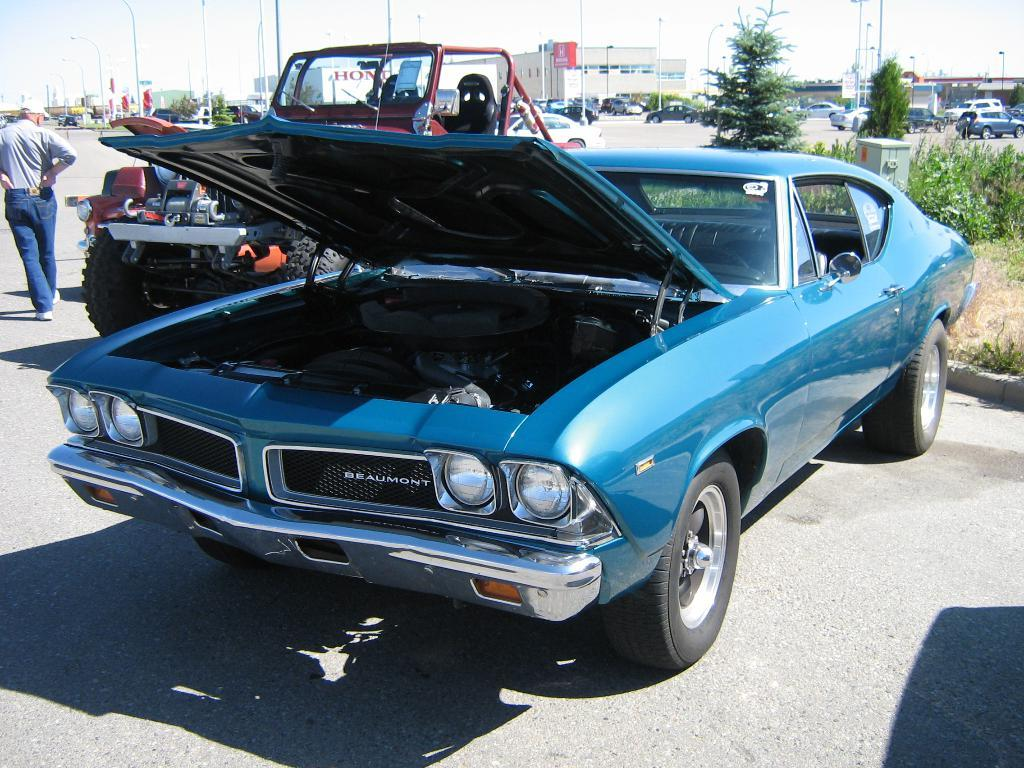What can be seen on the road in the image? There are vehicles on the road in the image. What is the man on the left side of the image doing? There is a man walking on the left side of the image. What can be seen in the background of the image? There are buildings, trees, poles, and the sky visible in the background of the image. How many bikes are parked on the rail in the image? There is no rail or bikes present in the image. What type of spot is visible on the man's shirt in the image? There is no spot visible on the man's shirt in the image. 